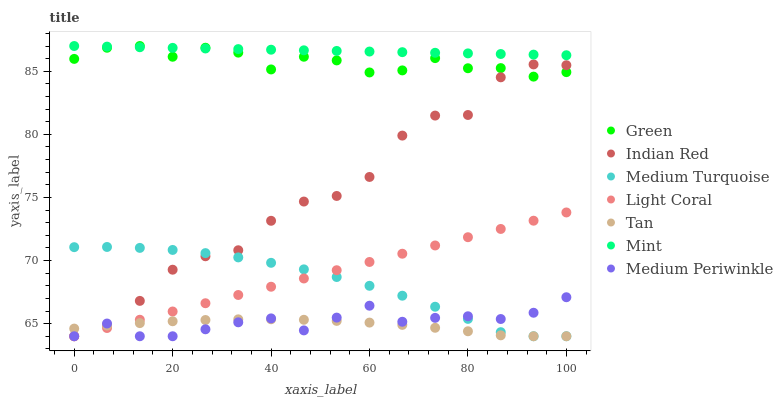Does Tan have the minimum area under the curve?
Answer yes or no. Yes. Does Mint have the maximum area under the curve?
Answer yes or no. Yes. Does Medium Periwinkle have the minimum area under the curve?
Answer yes or no. No. Does Medium Periwinkle have the maximum area under the curve?
Answer yes or no. No. Is Mint the smoothest?
Answer yes or no. Yes. Is Indian Red the roughest?
Answer yes or no. Yes. Is Medium Periwinkle the smoothest?
Answer yes or no. No. Is Medium Periwinkle the roughest?
Answer yes or no. No. Does Indian Red have the lowest value?
Answer yes or no. Yes. Does Green have the lowest value?
Answer yes or no. No. Does Mint have the highest value?
Answer yes or no. Yes. Does Medium Periwinkle have the highest value?
Answer yes or no. No. Is Medium Periwinkle less than Mint?
Answer yes or no. Yes. Is Mint greater than Tan?
Answer yes or no. Yes. Does Light Coral intersect Medium Periwinkle?
Answer yes or no. Yes. Is Light Coral less than Medium Periwinkle?
Answer yes or no. No. Is Light Coral greater than Medium Periwinkle?
Answer yes or no. No. Does Medium Periwinkle intersect Mint?
Answer yes or no. No. 